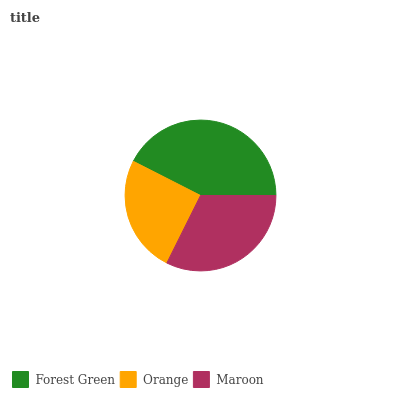Is Orange the minimum?
Answer yes or no. Yes. Is Forest Green the maximum?
Answer yes or no. Yes. Is Maroon the minimum?
Answer yes or no. No. Is Maroon the maximum?
Answer yes or no. No. Is Maroon greater than Orange?
Answer yes or no. Yes. Is Orange less than Maroon?
Answer yes or no. Yes. Is Orange greater than Maroon?
Answer yes or no. No. Is Maroon less than Orange?
Answer yes or no. No. Is Maroon the high median?
Answer yes or no. Yes. Is Maroon the low median?
Answer yes or no. Yes. Is Forest Green the high median?
Answer yes or no. No. Is Forest Green the low median?
Answer yes or no. No. 